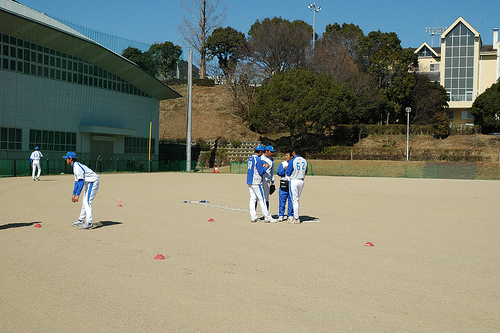<image>
Is the man above the ground? No. The man is not positioned above the ground. The vertical arrangement shows a different relationship. 